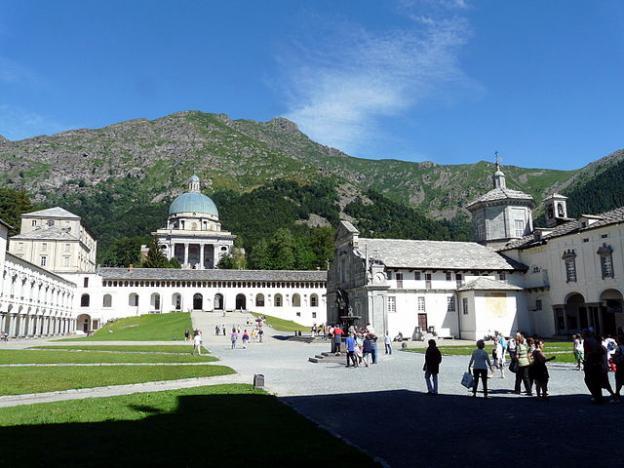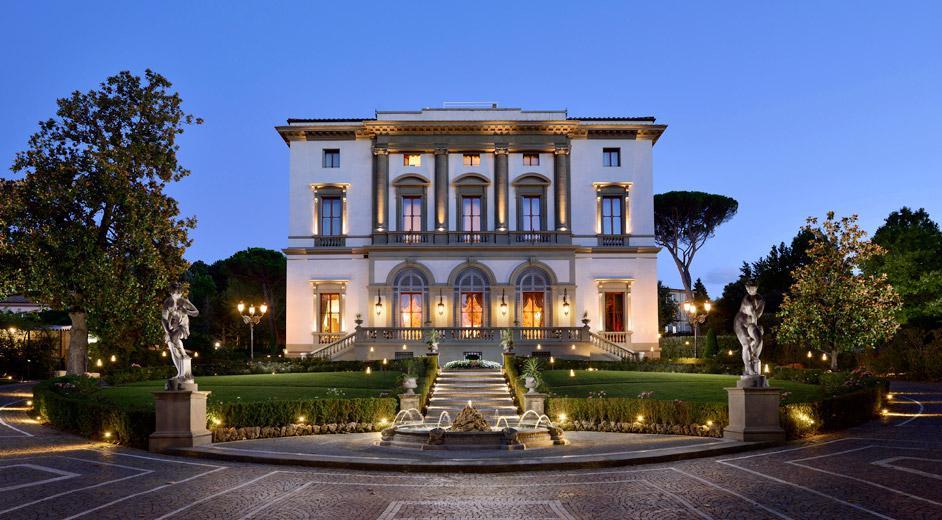The first image is the image on the left, the second image is the image on the right. For the images displayed, is the sentence "An image shows people walking down a wide paved path toward a row of arches with a dome-topped tower behind them." factually correct? Answer yes or no. Yes. The first image is the image on the left, the second image is the image on the right. Assess this claim about the two images: "There is a building with a blue dome in at least one of the images.". Correct or not? Answer yes or no. Yes. 